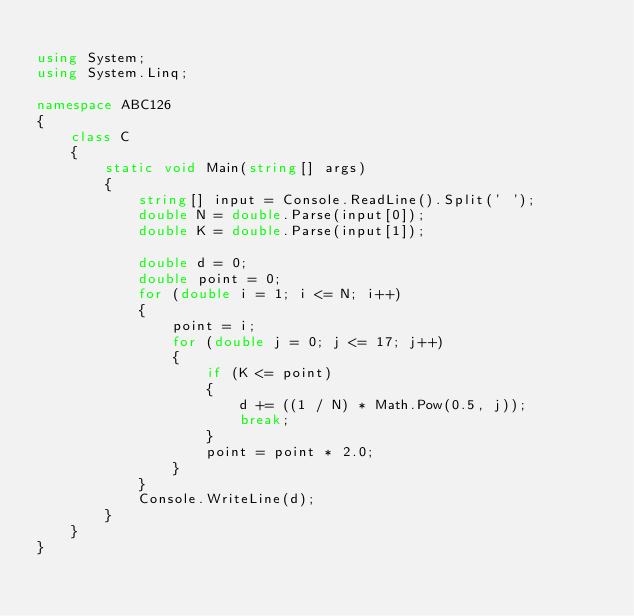Convert code to text. <code><loc_0><loc_0><loc_500><loc_500><_C#_>
using System;
using System.Linq;

namespace ABC126
{
    class C
    {
        static void Main(string[] args)
        {
            string[] input = Console.ReadLine().Split(' ');
            double N = double.Parse(input[0]);
            double K = double.Parse(input[1]);

            double d = 0;
            double point = 0;
            for (double i = 1; i <= N; i++)
            {
                point = i;
                for (double j = 0; j <= 17; j++)
                {
                    if (K <= point)
                    {
                        d += ((1 / N) * Math.Pow(0.5, j));
                        break;
                    }
                    point = point * 2.0;
                }
            }
            Console.WriteLine(d);
        }
    }
}
</code> 